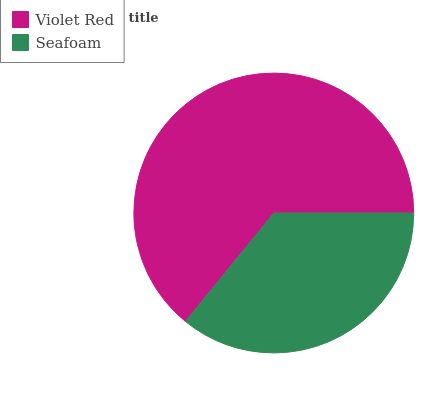Is Seafoam the minimum?
Answer yes or no. Yes. Is Violet Red the maximum?
Answer yes or no. Yes. Is Seafoam the maximum?
Answer yes or no. No. Is Violet Red greater than Seafoam?
Answer yes or no. Yes. Is Seafoam less than Violet Red?
Answer yes or no. Yes. Is Seafoam greater than Violet Red?
Answer yes or no. No. Is Violet Red less than Seafoam?
Answer yes or no. No. Is Violet Red the high median?
Answer yes or no. Yes. Is Seafoam the low median?
Answer yes or no. Yes. Is Seafoam the high median?
Answer yes or no. No. Is Violet Red the low median?
Answer yes or no. No. 